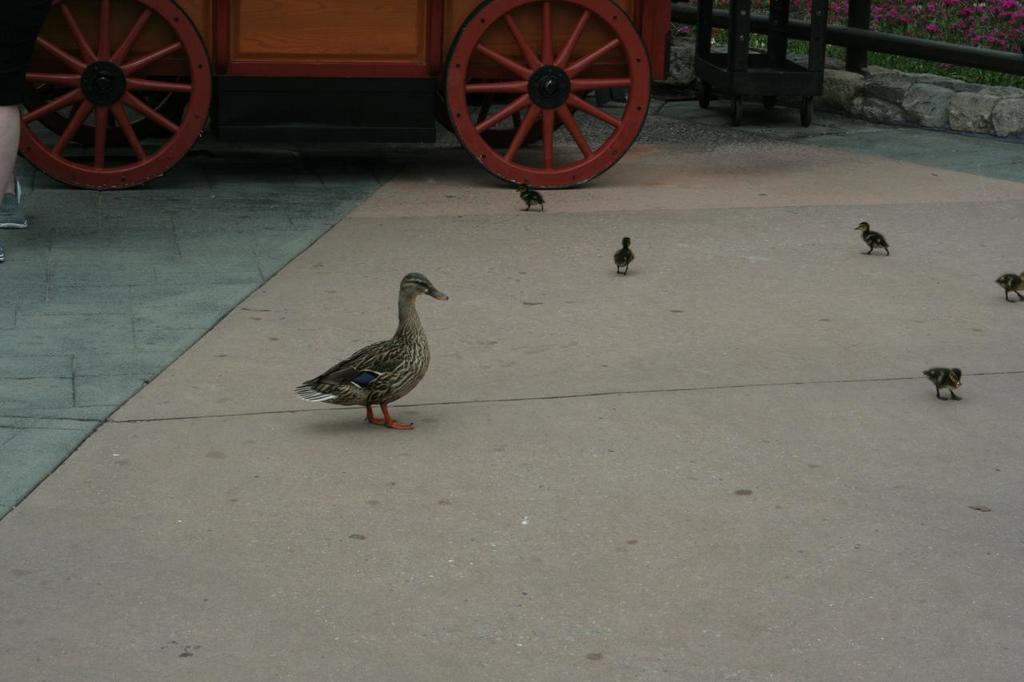Describe this image in one or two sentences. In this picture we can see birds on the surface, carts and rods. In the background of the image we can see flowers. 